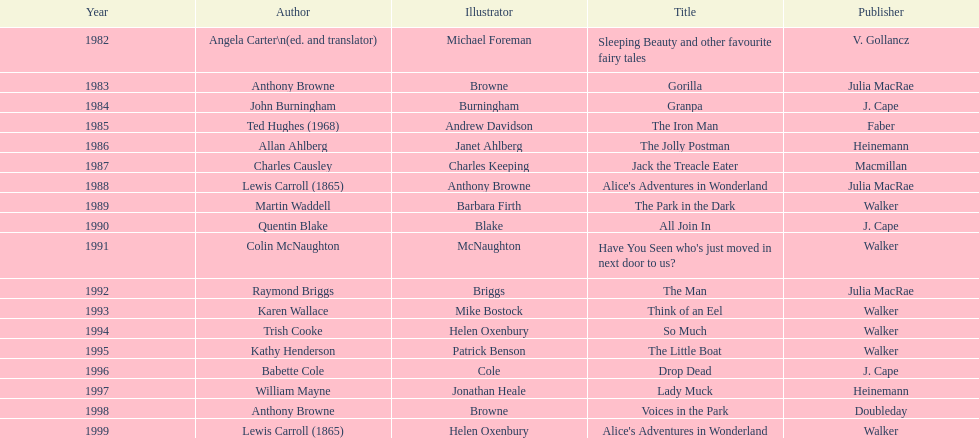Who is the author responsible for the first recognized literary work? Angela Carter. Could you help me parse every detail presented in this table? {'header': ['Year', 'Author', 'Illustrator', 'Title', 'Publisher'], 'rows': [['1982', 'Angela Carter\\n(ed. and translator)', 'Michael Foreman', 'Sleeping Beauty and other favourite fairy tales', 'V. Gollancz'], ['1983', 'Anthony Browne', 'Browne', 'Gorilla', 'Julia MacRae'], ['1984', 'John Burningham', 'Burningham', 'Granpa', 'J. Cape'], ['1985', 'Ted Hughes (1968)', 'Andrew Davidson', 'The Iron Man', 'Faber'], ['1986', 'Allan Ahlberg', 'Janet Ahlberg', 'The Jolly Postman', 'Heinemann'], ['1987', 'Charles Causley', 'Charles Keeping', 'Jack the Treacle Eater', 'Macmillan'], ['1988', 'Lewis Carroll (1865)', 'Anthony Browne', "Alice's Adventures in Wonderland", 'Julia MacRae'], ['1989', 'Martin Waddell', 'Barbara Firth', 'The Park in the Dark', 'Walker'], ['1990', 'Quentin Blake', 'Blake', 'All Join In', 'J. Cape'], ['1991', 'Colin McNaughton', 'McNaughton', "Have You Seen who's just moved in next door to us?", 'Walker'], ['1992', 'Raymond Briggs', 'Briggs', 'The Man', 'Julia MacRae'], ['1993', 'Karen Wallace', 'Mike Bostock', 'Think of an Eel', 'Walker'], ['1994', 'Trish Cooke', 'Helen Oxenbury', 'So Much', 'Walker'], ['1995', 'Kathy Henderson', 'Patrick Benson', 'The Little Boat', 'Walker'], ['1996', 'Babette Cole', 'Cole', 'Drop Dead', 'J. Cape'], ['1997', 'William Mayne', 'Jonathan Heale', 'Lady Muck', 'Heinemann'], ['1998', 'Anthony Browne', 'Browne', 'Voices in the Park', 'Doubleday'], ['1999', 'Lewis Carroll (1865)', 'Helen Oxenbury', "Alice's Adventures in Wonderland", 'Walker']]} 